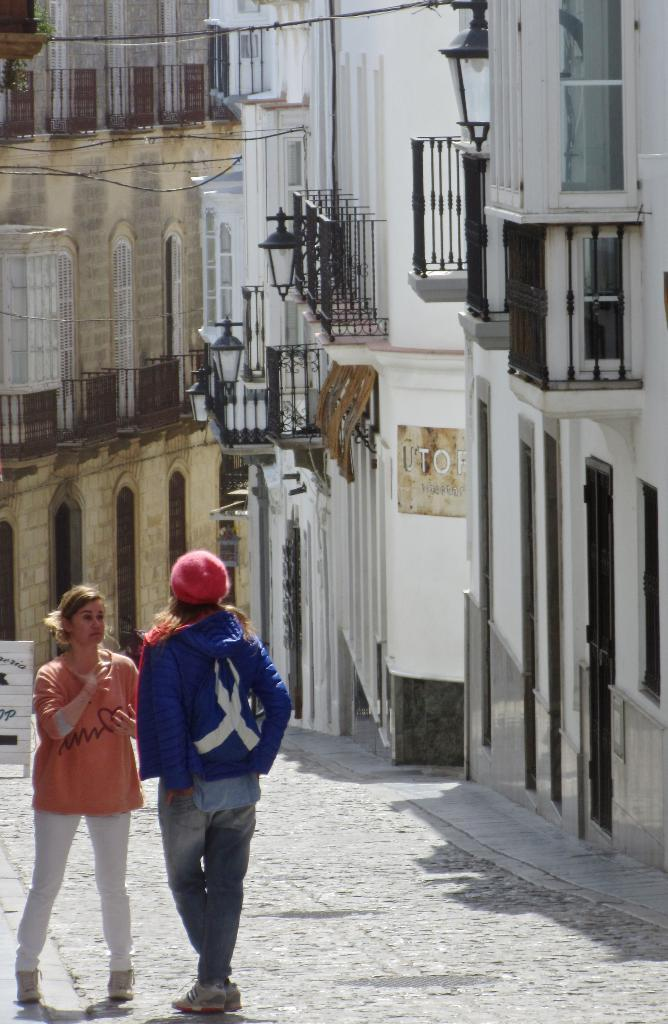How many women are present in the image? There are two women in the image. Where are the women located in the image? The women are standing on the street. What can be seen on the right side of the image? There are buildings on the right side of the image. What is the wooden board used for in the image? The wooden board is kept on the road, but its purpose is not specified in the image. What type of trousers is the woman on the left side of the image wearing? There is no information about the women's clothing in the image, so it cannot be determined what type of trousers the woman on the left side is wearing. 